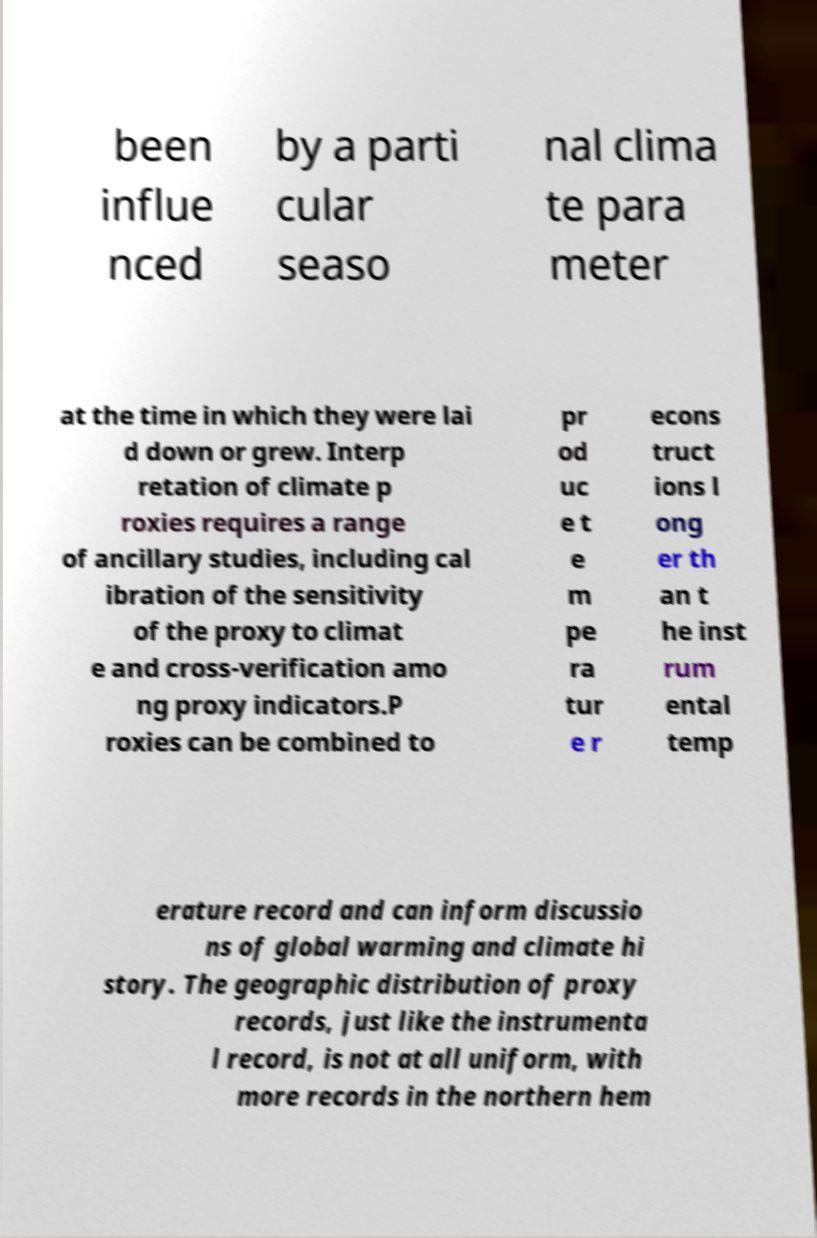Can you read and provide the text displayed in the image?This photo seems to have some interesting text. Can you extract and type it out for me? been influe nced by a parti cular seaso nal clima te para meter at the time in which they were lai d down or grew. Interp retation of climate p roxies requires a range of ancillary studies, including cal ibration of the sensitivity of the proxy to climat e and cross-verification amo ng proxy indicators.P roxies can be combined to pr od uc e t e m pe ra tur e r econs truct ions l ong er th an t he inst rum ental temp erature record and can inform discussio ns of global warming and climate hi story. The geographic distribution of proxy records, just like the instrumenta l record, is not at all uniform, with more records in the northern hem 